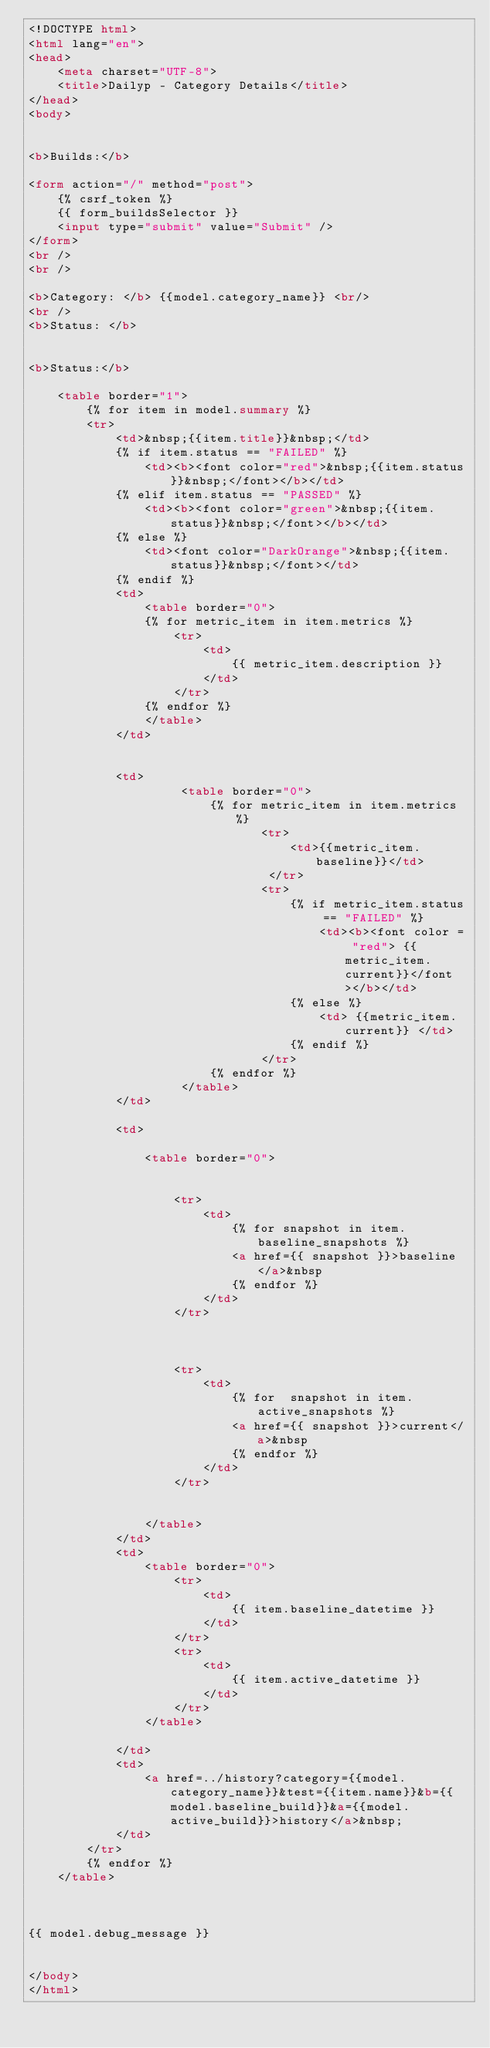Convert code to text. <code><loc_0><loc_0><loc_500><loc_500><_HTML_><!DOCTYPE html>
<html lang="en">
<head>
    <meta charset="UTF-8">
    <title>Dailyp - Category Details</title>
</head>
<body>


<b>Builds:</b>

<form action="/" method="post">
    {% csrf_token %}
    {{ form_buildsSelector }}
    <input type="submit" value="Submit" />
</form>
<br />
<br />

<b>Category: </b> {{model.category_name}} <br/>
<br />
<b>Status: </b>


<b>Status:</b>

    <table border="1">
        {% for item in model.summary %}
        <tr>
            <td>&nbsp;{{item.title}}&nbsp;</td>
            {% if item.status == "FAILED" %}
                <td><b><font color="red">&nbsp;{{item.status}}&nbsp;</font></b></td>
            {% elif item.status == "PASSED" %}
                <td><b><font color="green">&nbsp;{{item.status}}&nbsp;</font></b></td>
            {% else %}
                <td><font color="DarkOrange">&nbsp;{{item.status}}&nbsp;</font></td>
            {% endif %}
            <td>
                <table border="0">
                {% for metric_item in item.metrics %}
                    <tr>
                        <td>
                            {{ metric_item.description }}
                        </td>
                    </tr>
                {% endfor %}
                </table>
            </td>


            <td>
                     <table border="0">
                         {% for metric_item in item.metrics %}
                                <tr>
                                    <td>{{metric_item.baseline}}</td>
                                 </tr>
                                <tr>
                                    {% if metric_item.status == "FAILED" %}
                                        <td><b><font color = "red"> {{metric_item.current}}</font></b></td>
                                    {% else %}
                                        <td> {{metric_item.current}} </td>
                                    {% endif %}
                                </tr>
                         {% endfor %}
                     </table>
            </td>

            <td>

                <table border="0">


                    <tr>
                        <td>
                            {% for snapshot in item.baseline_snapshots %}
                            <a href={{ snapshot }}>baseline</a>&nbsp
                            {% endfor %}
                        </td>
                    </tr>



                    <tr>
                        <td>
                            {% for  snapshot in item.active_snapshots %}
                            <a href={{ snapshot }}>current</a>&nbsp
                            {% endfor %}
                        </td>
                    </tr>


                </table>
            </td>
            <td>
                <table border="0">
                    <tr>
                        <td>
                            {{ item.baseline_datetime }}
                        </td>
                    </tr>
                    <tr>
                        <td>
                            {{ item.active_datetime }}
                        </td>
                    </tr>
                </table>

            </td>
            <td>
                <a href=../history?category={{model.category_name}}&test={{item.name}}&b={{model.baseline_build}}&a={{model.active_build}}>history</a>&nbsp;
            </td>
        </tr>
        {% endfor %}
    </table>



{{ model.debug_message }}


</body>
</html>

</code> 